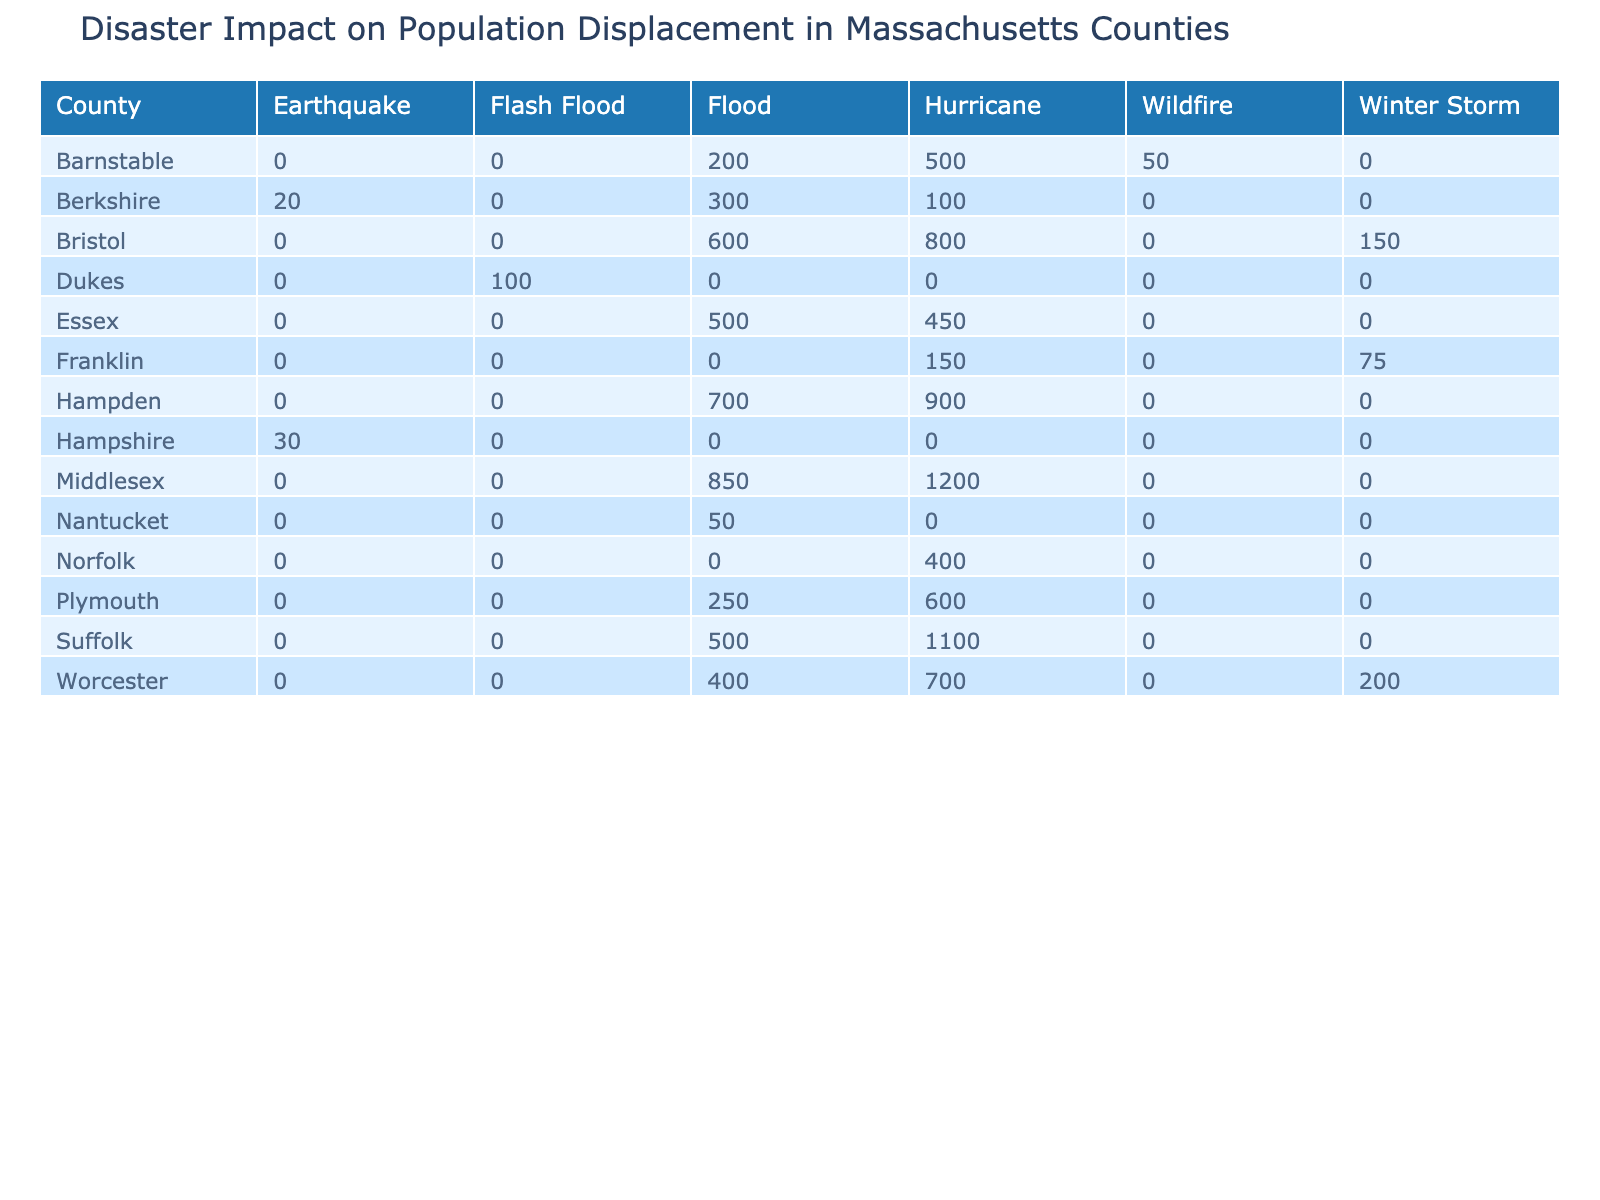What county had the highest population displaced by hurricanes? Looking at the hurricane column, I see that Middlesex has 1200 people displaced, which is the highest value compared to other counties.
Answer: Middlesex What is the total population displaced by floods across all counties? To find the total, I will sum the values in the flood column: 200 (Barnstable) + 300 (Berkshire) + 600 (Bristol) + 500 (Essex) + 700 (Hampden) + 250 (Plymouth) + 500 (Suffolk) + 400 (Worcester) + 50 (Nantucket) = 4050.
Answer: 4050 Did any county experience population displacement due to an earthquake? Looking at the table, I see that Berkshire (20 displaced) and Hampshire (30 displaced) have values in the earthquake row, confirming that they did.
Answer: Yes Which disaster type resulted in the least population displacement in Barnstable? In the Barnstable row under disaster types, wildfire has the lowest displacement value at 50, compared to hurricane (500) and flood (200).
Answer: Wildfire What is the difference in population displacement between hurricanes and floods for Bristol County? For Bristol County, population displaced by hurricanes is 800 and by floods is 600. The difference is calculated as 800 - 600 = 200.
Answer: 200 Which county had the highest total population displacement across all disaster types? I will calculate the total for each county by summing up all their respective values. The totals are: Barnstable (750), Berkshire (420), Bristol (1550), Dukes (100), Essex (950), Franklin (225), Hampden (1600), Hampshire (30), Middlesex (2050), Nantucket (50), Norfolk (400), Plymouth (850), Suffolk (1600), Worcester (1300). The highest is Hampden with 1600 displaced.
Answer: Hampden Were there more people displaced by hurricanes in Suffolk compared to floods in the same county? In Suffolk County, 1100 people were displaced by hurricanes and 500 by floods. Since 1100 is greater than 500, the answer is yes.
Answer: Yes What is the total population displaced by wildfires in Massachusetts? From the table, wildfires displaced 50 (Barnstable) and there are no other entries for wildfires in other counties. Thus, the total is simply 50.
Answer: 50 